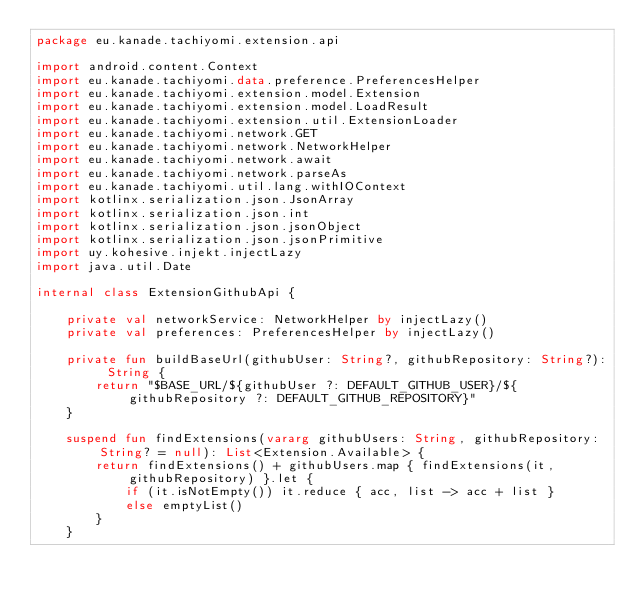<code> <loc_0><loc_0><loc_500><loc_500><_Kotlin_>package eu.kanade.tachiyomi.extension.api

import android.content.Context
import eu.kanade.tachiyomi.data.preference.PreferencesHelper
import eu.kanade.tachiyomi.extension.model.Extension
import eu.kanade.tachiyomi.extension.model.LoadResult
import eu.kanade.tachiyomi.extension.util.ExtensionLoader
import eu.kanade.tachiyomi.network.GET
import eu.kanade.tachiyomi.network.NetworkHelper
import eu.kanade.tachiyomi.network.await
import eu.kanade.tachiyomi.network.parseAs
import eu.kanade.tachiyomi.util.lang.withIOContext
import kotlinx.serialization.json.JsonArray
import kotlinx.serialization.json.int
import kotlinx.serialization.json.jsonObject
import kotlinx.serialization.json.jsonPrimitive
import uy.kohesive.injekt.injectLazy
import java.util.Date

internal class ExtensionGithubApi {

    private val networkService: NetworkHelper by injectLazy()
    private val preferences: PreferencesHelper by injectLazy()

    private fun buildBaseUrl(githubUser: String?, githubRepository: String?): String {
        return "$BASE_URL/${githubUser ?: DEFAULT_GITHUB_USER}/${githubRepository ?: DEFAULT_GITHUB_REPOSITORY}"
    }

    suspend fun findExtensions(vararg githubUsers: String, githubRepository: String? = null): List<Extension.Available> {
        return findExtensions() + githubUsers.map { findExtensions(it, githubRepository) }.let {
            if (it.isNotEmpty()) it.reduce { acc, list -> acc + list }
            else emptyList()
        }
    }
</code> 